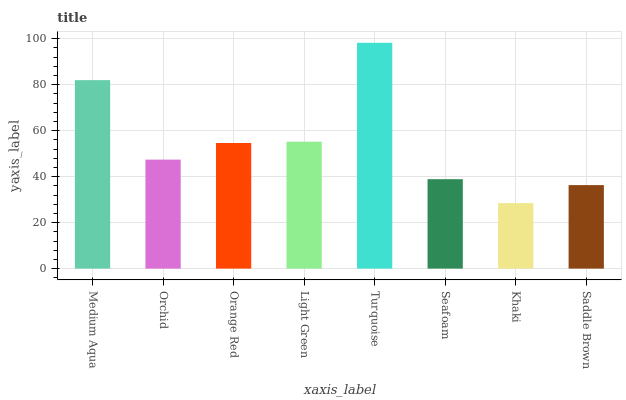Is Khaki the minimum?
Answer yes or no. Yes. Is Turquoise the maximum?
Answer yes or no. Yes. Is Orchid the minimum?
Answer yes or no. No. Is Orchid the maximum?
Answer yes or no. No. Is Medium Aqua greater than Orchid?
Answer yes or no. Yes. Is Orchid less than Medium Aqua?
Answer yes or no. Yes. Is Orchid greater than Medium Aqua?
Answer yes or no. No. Is Medium Aqua less than Orchid?
Answer yes or no. No. Is Orange Red the high median?
Answer yes or no. Yes. Is Orchid the low median?
Answer yes or no. Yes. Is Saddle Brown the high median?
Answer yes or no. No. Is Turquoise the low median?
Answer yes or no. No. 